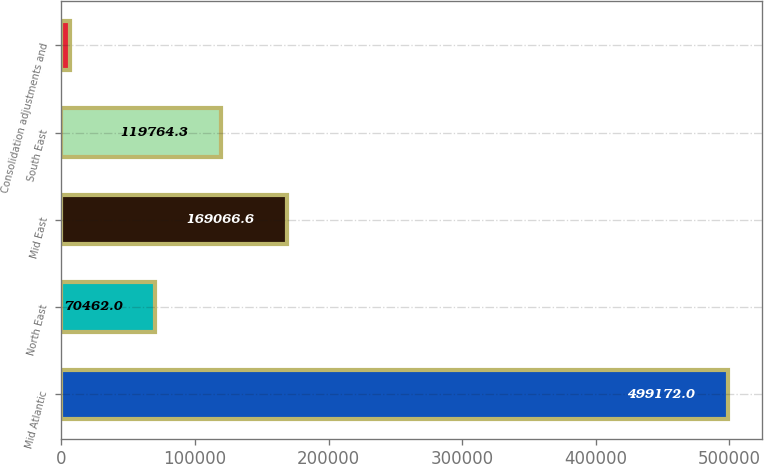Convert chart to OTSL. <chart><loc_0><loc_0><loc_500><loc_500><bar_chart><fcel>Mid Atlantic<fcel>North East<fcel>Mid East<fcel>South East<fcel>Consolidation adjustments and<nl><fcel>499172<fcel>70462<fcel>169067<fcel>119764<fcel>6149<nl></chart> 